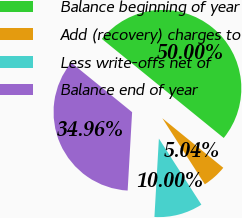Convert chart. <chart><loc_0><loc_0><loc_500><loc_500><pie_chart><fcel>Balance beginning of year<fcel>Add (recovery) charges to<fcel>Less write-offs net of<fcel>Balance end of year<nl><fcel>50.0%<fcel>5.04%<fcel>10.0%<fcel>34.96%<nl></chart> 